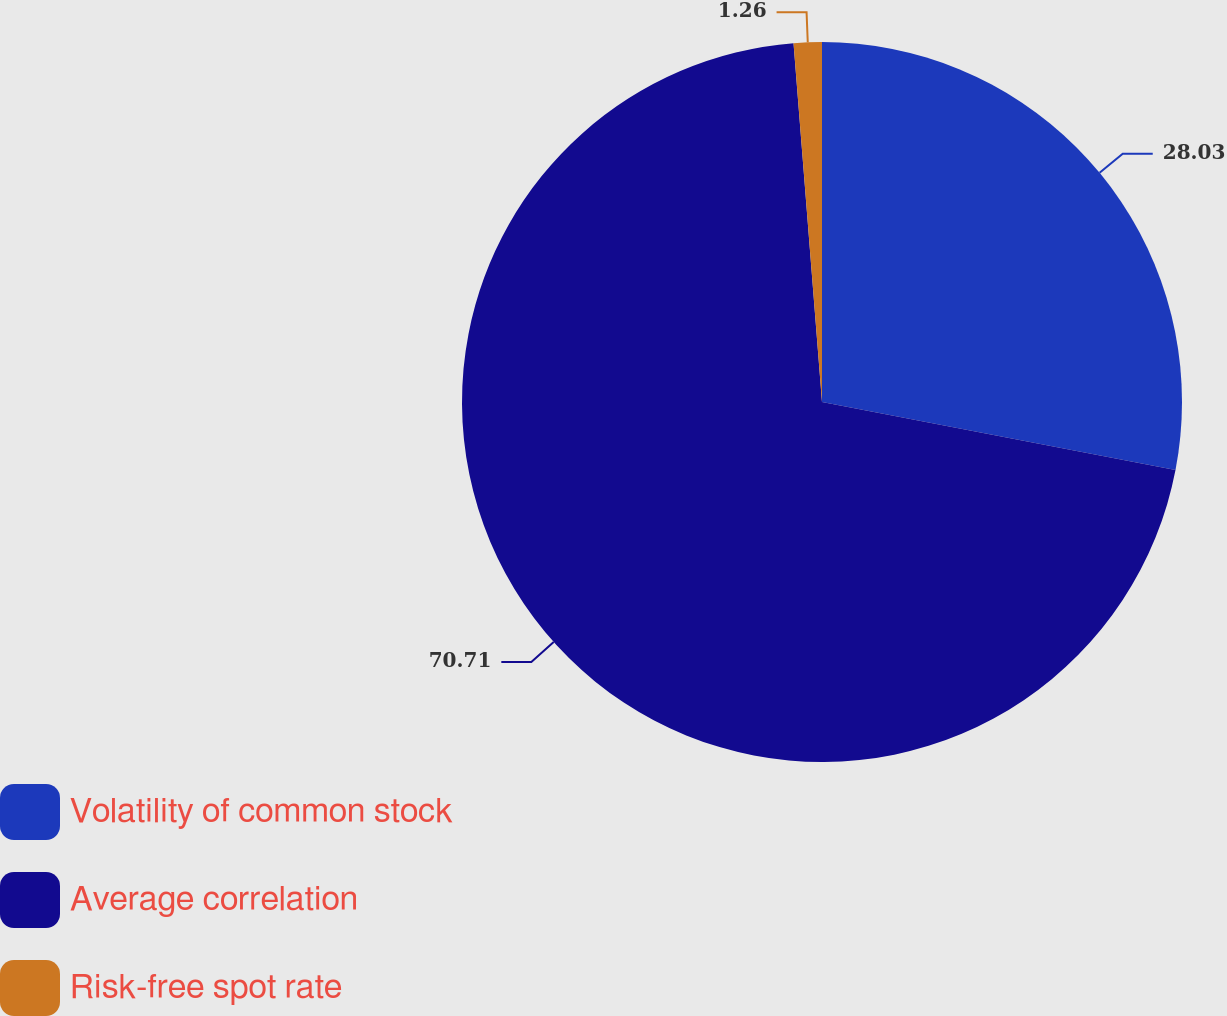<chart> <loc_0><loc_0><loc_500><loc_500><pie_chart><fcel>Volatility of common stock<fcel>Average correlation<fcel>Risk-free spot rate<nl><fcel>28.03%<fcel>70.71%<fcel>1.26%<nl></chart> 